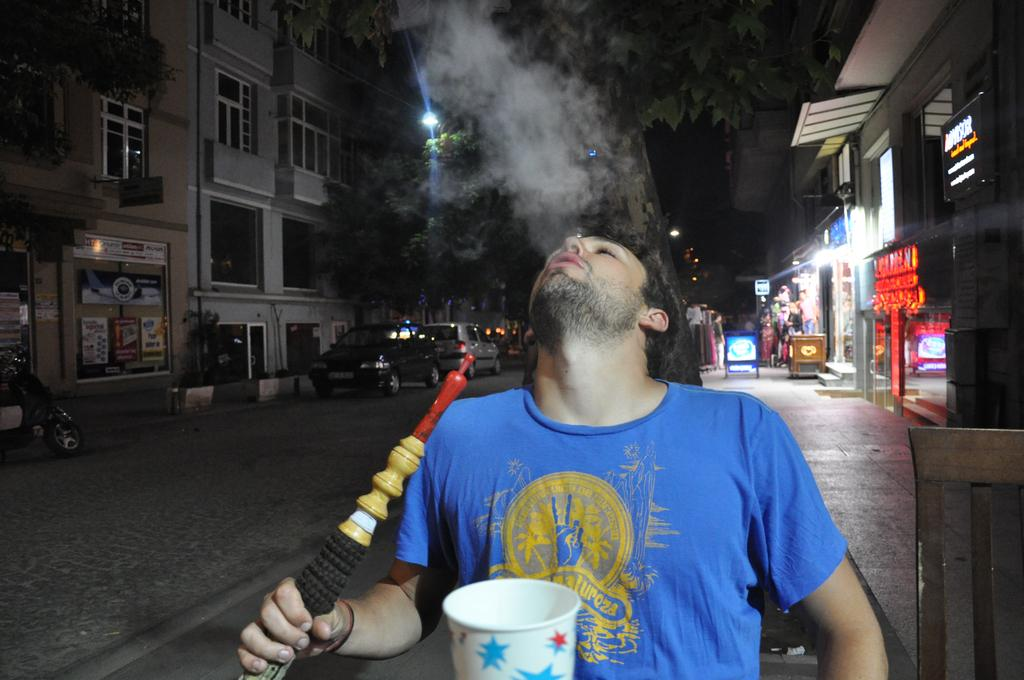What is the main subject of the image? There is a person standing in the image. What can be seen in the background of the image? There is a building and vehicles on the road in the background of the image. What type of vegetation is present in the image? There is a tree in the image. What type of establishment is located on the right side of the image? There is a store on the right side of the image. What type of books can be seen in the fog in the image? There is no fog or books present in the image. What type of amusement can be seen in the image? There is no amusement present in the image; it features a person, a building, vehicles, a tree, and a store. 